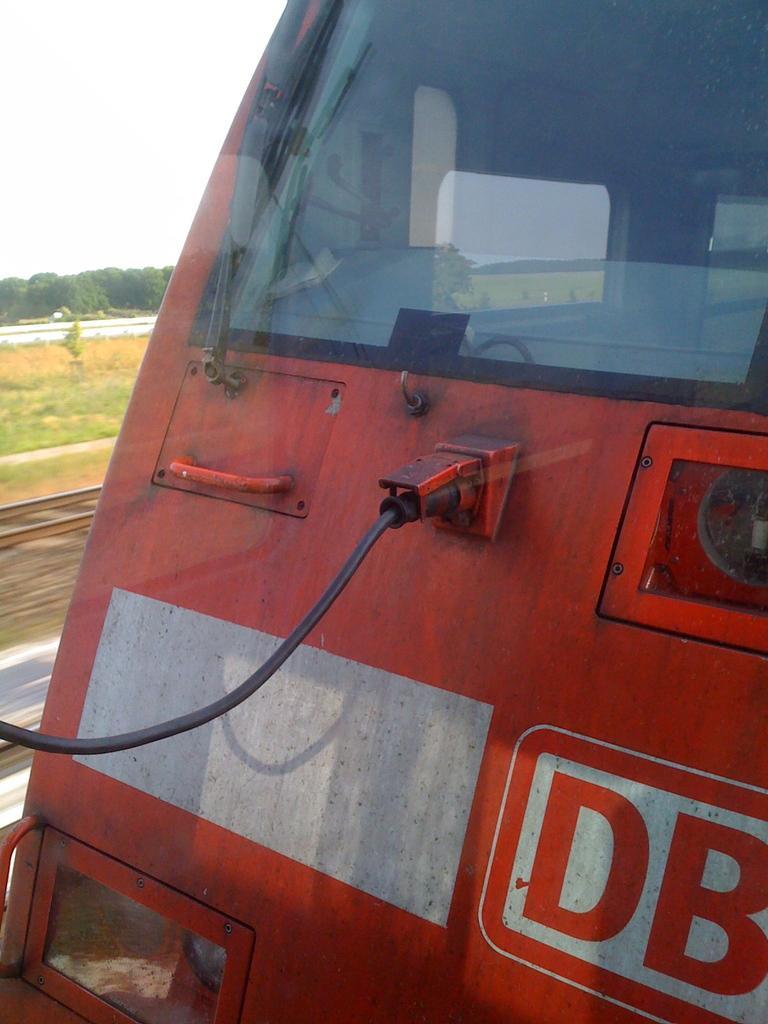In one or two sentences, can you explain what this image depicts? In this image we can see the front part of the train, beside the train there's grass on the surface, beside the grass there are trees. 